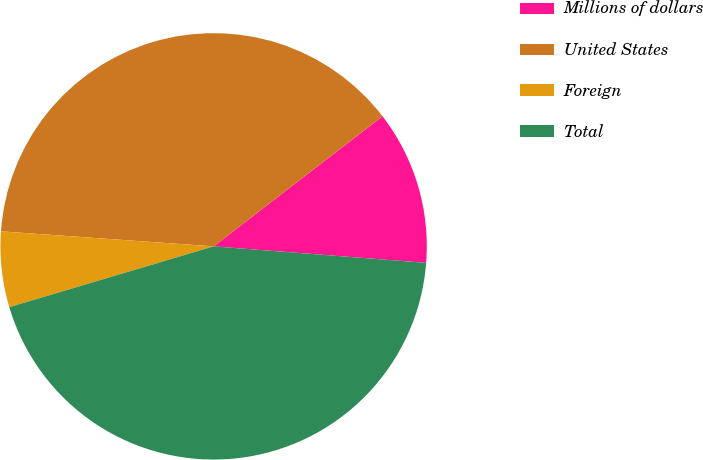Convert chart. <chart><loc_0><loc_0><loc_500><loc_500><pie_chart><fcel>Millions of dollars<fcel>United States<fcel>Foreign<fcel>Total<nl><fcel>11.68%<fcel>38.43%<fcel>5.73%<fcel>44.16%<nl></chart> 